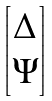<formula> <loc_0><loc_0><loc_500><loc_500>\begin{bmatrix} \Delta \\ \Psi \end{bmatrix}</formula> 